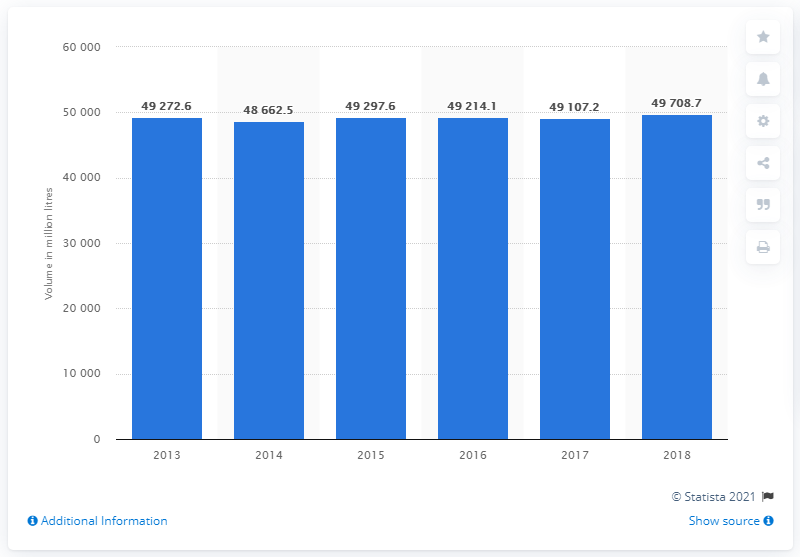Highlight a few significant elements in this photo. In 2013, the EU consumed a total of 49,708.7 liters of soft drinks. 